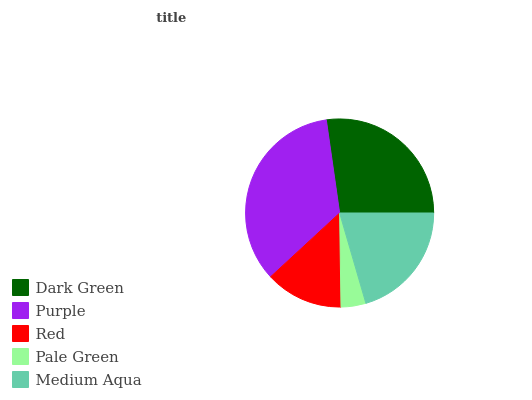Is Pale Green the minimum?
Answer yes or no. Yes. Is Purple the maximum?
Answer yes or no. Yes. Is Red the minimum?
Answer yes or no. No. Is Red the maximum?
Answer yes or no. No. Is Purple greater than Red?
Answer yes or no. Yes. Is Red less than Purple?
Answer yes or no. Yes. Is Red greater than Purple?
Answer yes or no. No. Is Purple less than Red?
Answer yes or no. No. Is Medium Aqua the high median?
Answer yes or no. Yes. Is Medium Aqua the low median?
Answer yes or no. Yes. Is Dark Green the high median?
Answer yes or no. No. Is Dark Green the low median?
Answer yes or no. No. 